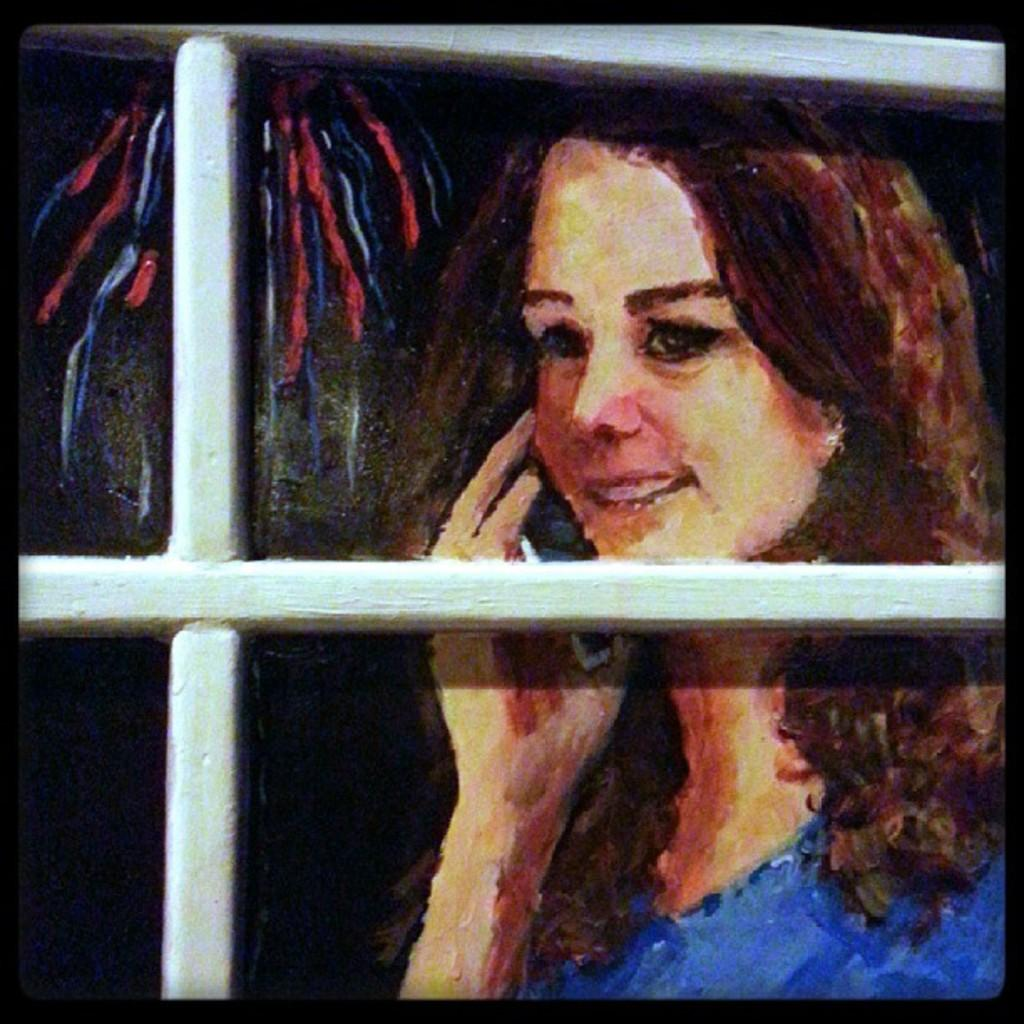What type of artwork is depicted in the image? The image is a painting. What architectural feature can be seen in the painting? There is a window in the image. What object is the person holding in the painting? The person is holding a mobile in the image. What type of dinner is being served in the image? There is no dinner present in the image; it is a painting featuring a person holding a mobile and a window. What relation does the person in the painting have to the artist? The provided facts do not give any information about the person's relation to the artist, so we cannot determine that from the image. 